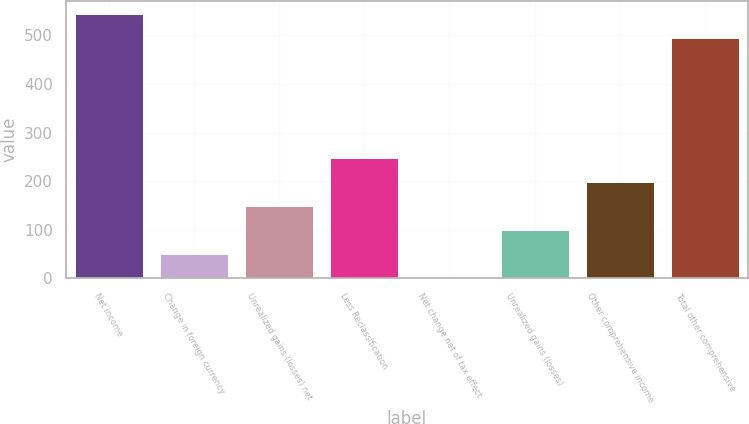<chart> <loc_0><loc_0><loc_500><loc_500><bar_chart><fcel>Net income<fcel>Change in foreign currency<fcel>Unrealized gains (losses) net<fcel>Less Reclassification<fcel>Net change net of tax effect<fcel>Unrealized gains (losses)<fcel>Other comprehensive income<fcel>Total other comprehensive<nl><fcel>543.89<fcel>49.69<fcel>148.67<fcel>247.65<fcel>0.2<fcel>99.18<fcel>198.16<fcel>494.4<nl></chart> 